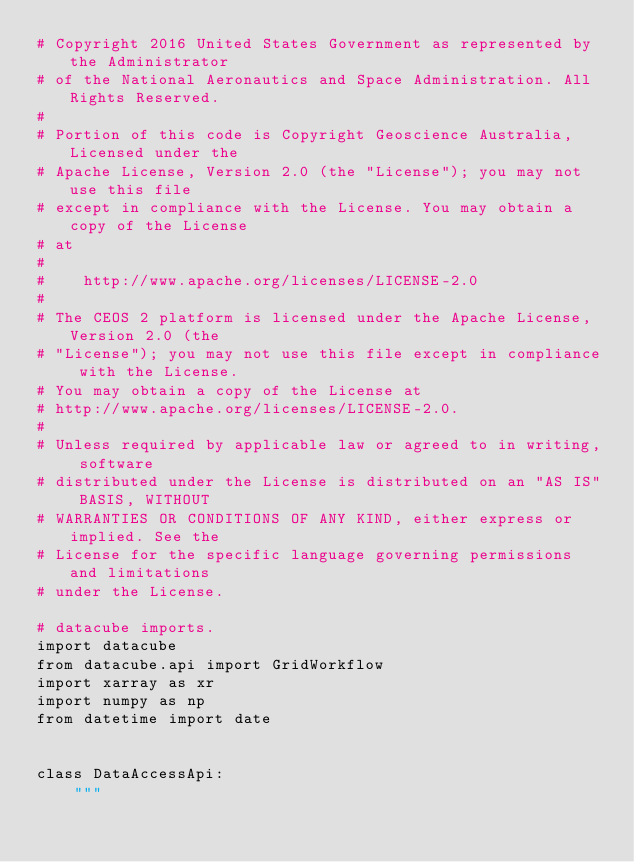Convert code to text. <code><loc_0><loc_0><loc_500><loc_500><_Python_># Copyright 2016 United States Government as represented by the Administrator
# of the National Aeronautics and Space Administration. All Rights Reserved.
#
# Portion of this code is Copyright Geoscience Australia, Licensed under the
# Apache License, Version 2.0 (the "License"); you may not use this file
# except in compliance with the License. You may obtain a copy of the License
# at
#
#    http://www.apache.org/licenses/LICENSE-2.0
#
# The CEOS 2 platform is licensed under the Apache License, Version 2.0 (the
# "License"); you may not use this file except in compliance with the License.
# You may obtain a copy of the License at
# http://www.apache.org/licenses/LICENSE-2.0.
#
# Unless required by applicable law or agreed to in writing, software
# distributed under the License is distributed on an "AS IS" BASIS, WITHOUT
# WARRANTIES OR CONDITIONS OF ANY KIND, either express or implied. See the
# License for the specific language governing permissions and limitations
# under the License.

# datacube imports.
import datacube
from datacube.api import GridWorkflow
import xarray as xr
import numpy as np
from datetime import date


class DataAccessApi:
    """</code> 